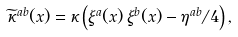<formula> <loc_0><loc_0><loc_500><loc_500>\widetilde { \kappa } ^ { a b } ( x ) = \kappa \left ( \xi ^ { a } ( x ) \, \xi ^ { b } ( x ) - \eta ^ { a b } / 4 \right ) ,</formula> 